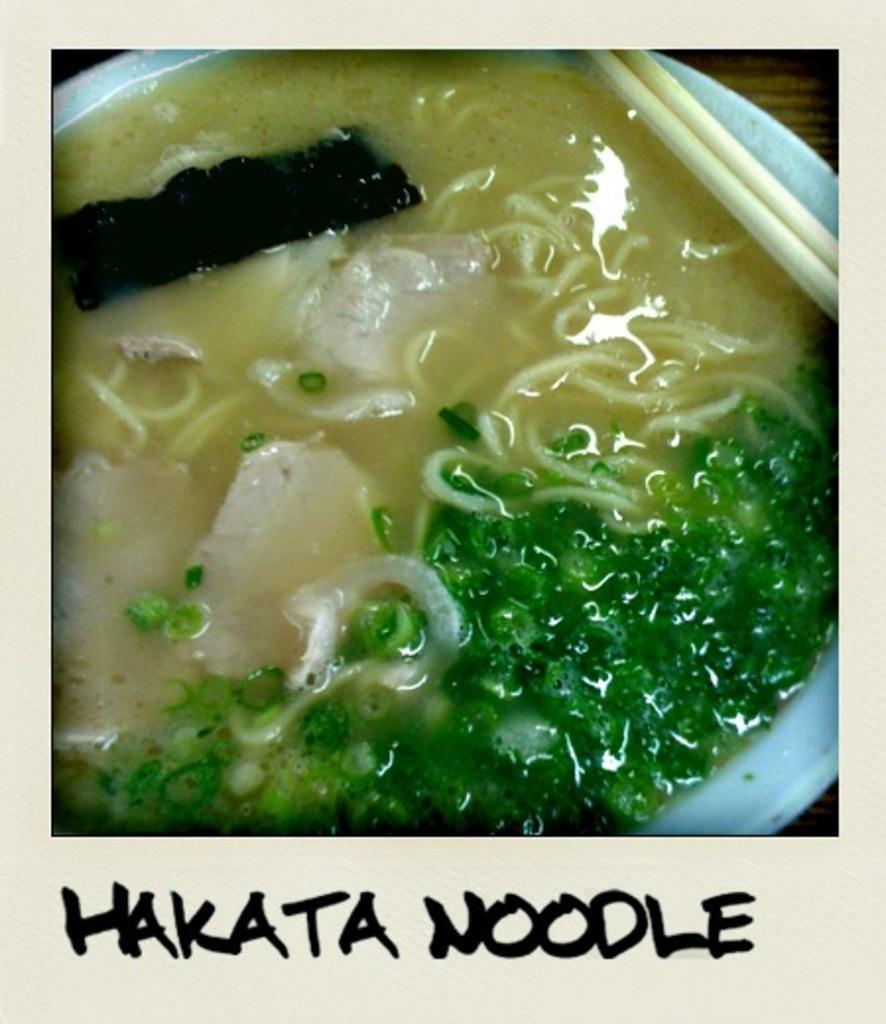Describe this image in one or two sentences. In this image we can see some food and chopsticks in a plate which is placed on the table. On the bottom of the image we can see some text. 